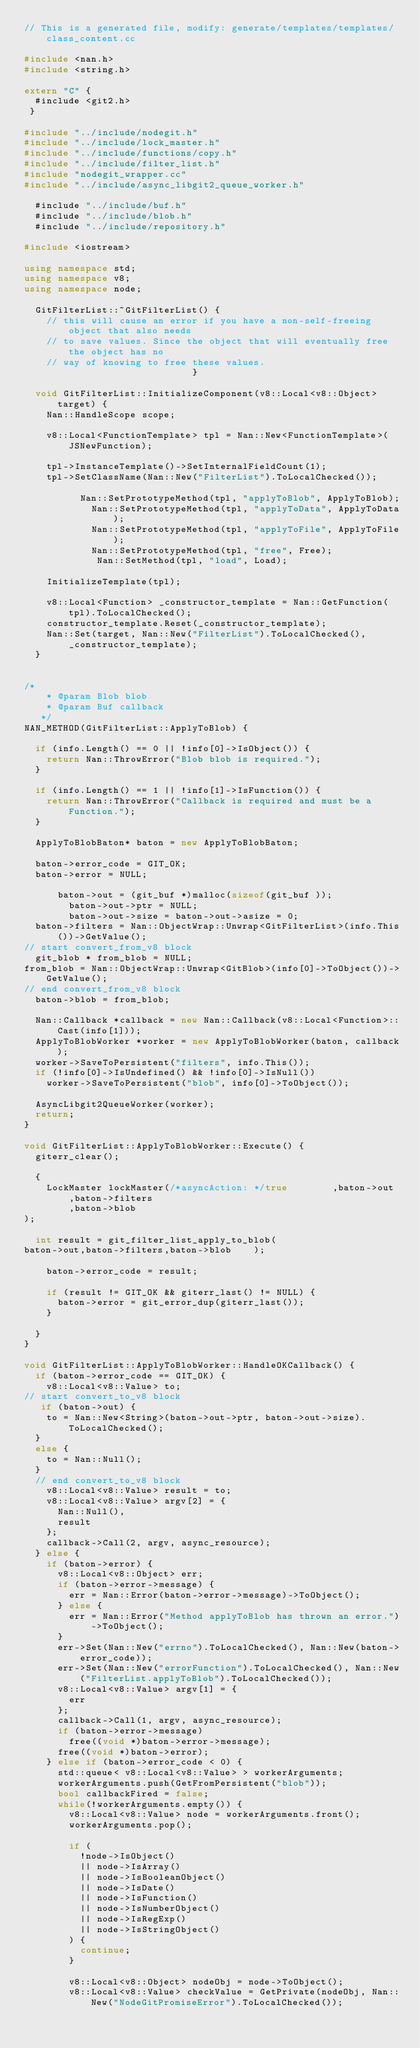<code> <loc_0><loc_0><loc_500><loc_500><_C++_>// This is a generated file, modify: generate/templates/templates/class_content.cc

#include <nan.h>
#include <string.h>

extern "C" {
  #include <git2.h>
 }

#include "../include/nodegit.h"
#include "../include/lock_master.h"
#include "../include/functions/copy.h"
#include "../include/filter_list.h"
#include "nodegit_wrapper.cc"
#include "../include/async_libgit2_queue_worker.h"

  #include "../include/buf.h"
  #include "../include/blob.h"
  #include "../include/repository.h"
 
#include <iostream>

using namespace std;
using namespace v8;
using namespace node;

  GitFilterList::~GitFilterList() {
    // this will cause an error if you have a non-self-freeing object that also needs
    // to save values. Since the object that will eventually free the object has no
    // way of knowing to free these values.
                              }

  void GitFilterList::InitializeComponent(v8::Local<v8::Object> target) {
    Nan::HandleScope scope;

    v8::Local<FunctionTemplate> tpl = Nan::New<FunctionTemplate>(JSNewFunction);

    tpl->InstanceTemplate()->SetInternalFieldCount(1);
    tpl->SetClassName(Nan::New("FilterList").ToLocalChecked());

          Nan::SetPrototypeMethod(tpl, "applyToBlob", ApplyToBlob);
            Nan::SetPrototypeMethod(tpl, "applyToData", ApplyToData);
            Nan::SetPrototypeMethod(tpl, "applyToFile", ApplyToFile);
            Nan::SetPrototypeMethod(tpl, "free", Free);
             Nan::SetMethod(tpl, "load", Load);
    
    InitializeTemplate(tpl);

    v8::Local<Function> _constructor_template = Nan::GetFunction(tpl).ToLocalChecked();
    constructor_template.Reset(_constructor_template);
    Nan::Set(target, Nan::New("FilterList").ToLocalChecked(), _constructor_template);
  }

 
/*
    * @param Blob blob
    * @param Buf callback
   */
NAN_METHOD(GitFilterList::ApplyToBlob) {

  if (info.Length() == 0 || !info[0]->IsObject()) {
    return Nan::ThrowError("Blob blob is required.");
  }

  if (info.Length() == 1 || !info[1]->IsFunction()) {
    return Nan::ThrowError("Callback is required and must be a Function.");
  }

  ApplyToBlobBaton* baton = new ApplyToBlobBaton;

  baton->error_code = GIT_OK;
  baton->error = NULL;

      baton->out = (git_buf *)malloc(sizeof(git_buf ));
        baton->out->ptr = NULL;
        baton->out->size = baton->out->asize = 0;
  baton->filters = Nan::ObjectWrap::Unwrap<GitFilterList>(info.This())->GetValue();
// start convert_from_v8 block
  git_blob * from_blob = NULL;
from_blob = Nan::ObjectWrap::Unwrap<GitBlob>(info[0]->ToObject())->GetValue();
// end convert_from_v8 block
  baton->blob = from_blob;

  Nan::Callback *callback = new Nan::Callback(v8::Local<Function>::Cast(info[1]));
  ApplyToBlobWorker *worker = new ApplyToBlobWorker(baton, callback);
  worker->SaveToPersistent("filters", info.This());
  if (!info[0]->IsUndefined() && !info[0]->IsNull())
    worker->SaveToPersistent("blob", info[0]->ToObject());

  AsyncLibgit2QueueWorker(worker);
  return;
}

void GitFilterList::ApplyToBlobWorker::Execute() {
  giterr_clear();

  {
    LockMaster lockMaster(/*asyncAction: */true        ,baton->out
        ,baton->filters
        ,baton->blob
);

  int result = git_filter_list_apply_to_blob(
baton->out,baton->filters,baton->blob    );

    baton->error_code = result;

    if (result != GIT_OK && giterr_last() != NULL) {
      baton->error = git_error_dup(giterr_last());
    }

  }
}

void GitFilterList::ApplyToBlobWorker::HandleOKCallback() {
  if (baton->error_code == GIT_OK) {
    v8::Local<v8::Value> to;
// start convert_to_v8 block
   if (baton->out) {
    to = Nan::New<String>(baton->out->ptr, baton->out->size).ToLocalChecked();
  }
  else {
    to = Nan::Null();
  }
  // end convert_to_v8 block
    v8::Local<v8::Value> result = to;
    v8::Local<v8::Value> argv[2] = {
      Nan::Null(),
      result
    };
    callback->Call(2, argv, async_resource);
  } else {
    if (baton->error) {
      v8::Local<v8::Object> err;
      if (baton->error->message) {
        err = Nan::Error(baton->error->message)->ToObject();
      } else {
        err = Nan::Error("Method applyToBlob has thrown an error.")->ToObject();
      }
      err->Set(Nan::New("errno").ToLocalChecked(), Nan::New(baton->error_code));
      err->Set(Nan::New("errorFunction").ToLocalChecked(), Nan::New("FilterList.applyToBlob").ToLocalChecked());
      v8::Local<v8::Value> argv[1] = {
        err
      };
      callback->Call(1, argv, async_resource);
      if (baton->error->message)
        free((void *)baton->error->message);
      free((void *)baton->error);
    } else if (baton->error_code < 0) {
      std::queue< v8::Local<v8::Value> > workerArguments;
      workerArguments.push(GetFromPersistent("blob"));
      bool callbackFired = false;
      while(!workerArguments.empty()) {
        v8::Local<v8::Value> node = workerArguments.front();
        workerArguments.pop();

        if (
          !node->IsObject()
          || node->IsArray()
          || node->IsBooleanObject()
          || node->IsDate()
          || node->IsFunction()
          || node->IsNumberObject()
          || node->IsRegExp()
          || node->IsStringObject()
        ) {
          continue;
        }

        v8::Local<v8::Object> nodeObj = node->ToObject();
        v8::Local<v8::Value> checkValue = GetPrivate(nodeObj, Nan::New("NodeGitPromiseError").ToLocalChecked());
</code> 